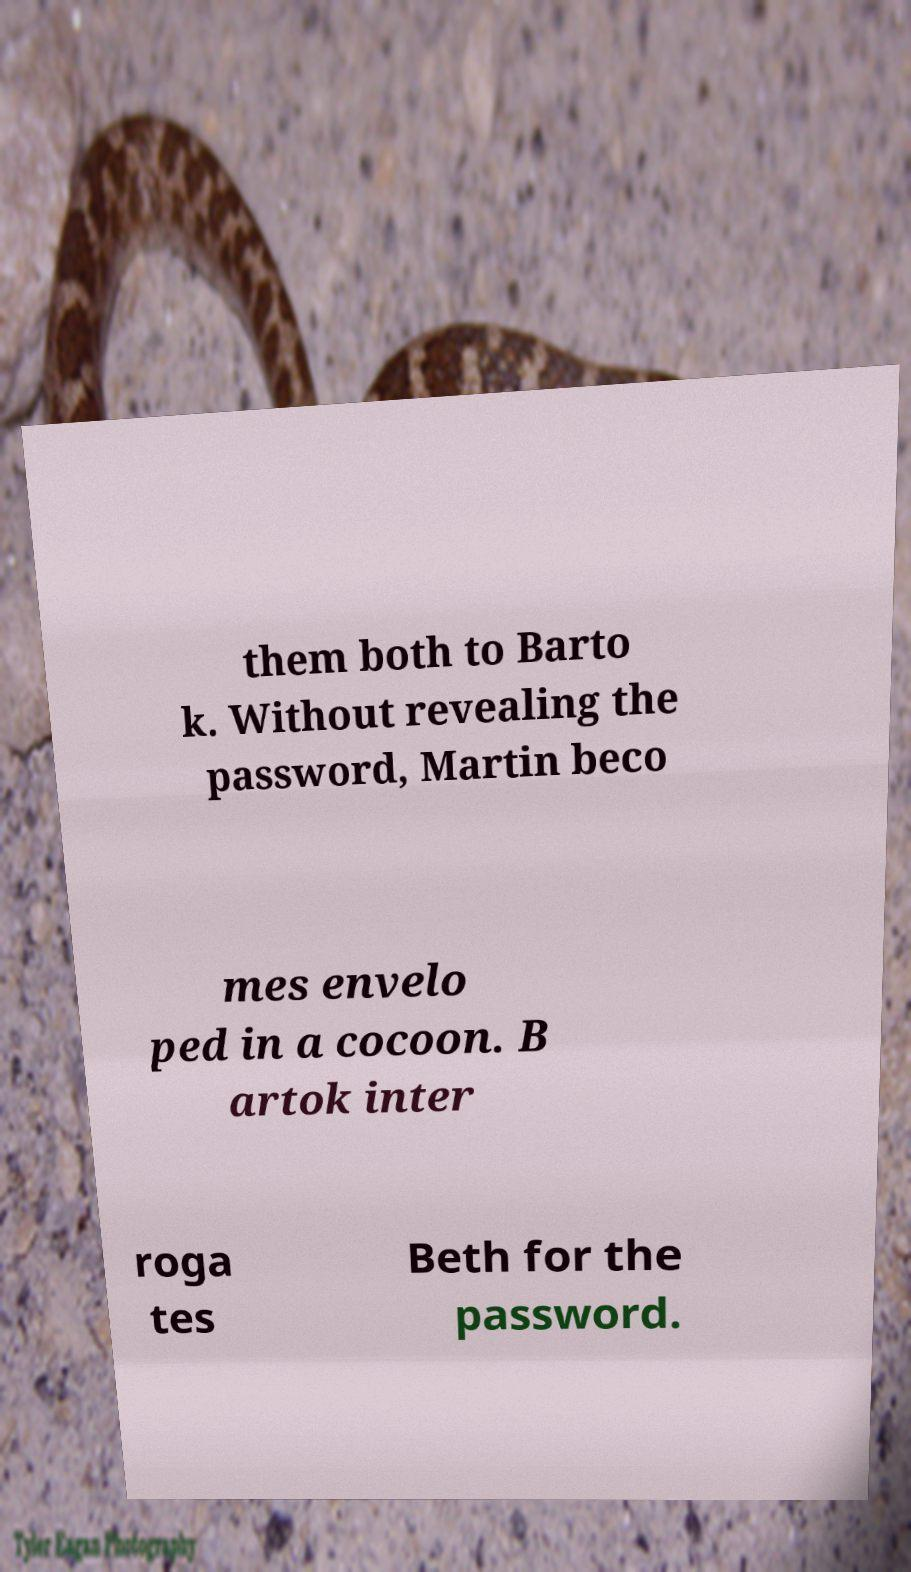Could you assist in decoding the text presented in this image and type it out clearly? them both to Barto k. Without revealing the password, Martin beco mes envelo ped in a cocoon. B artok inter roga tes Beth for the password. 